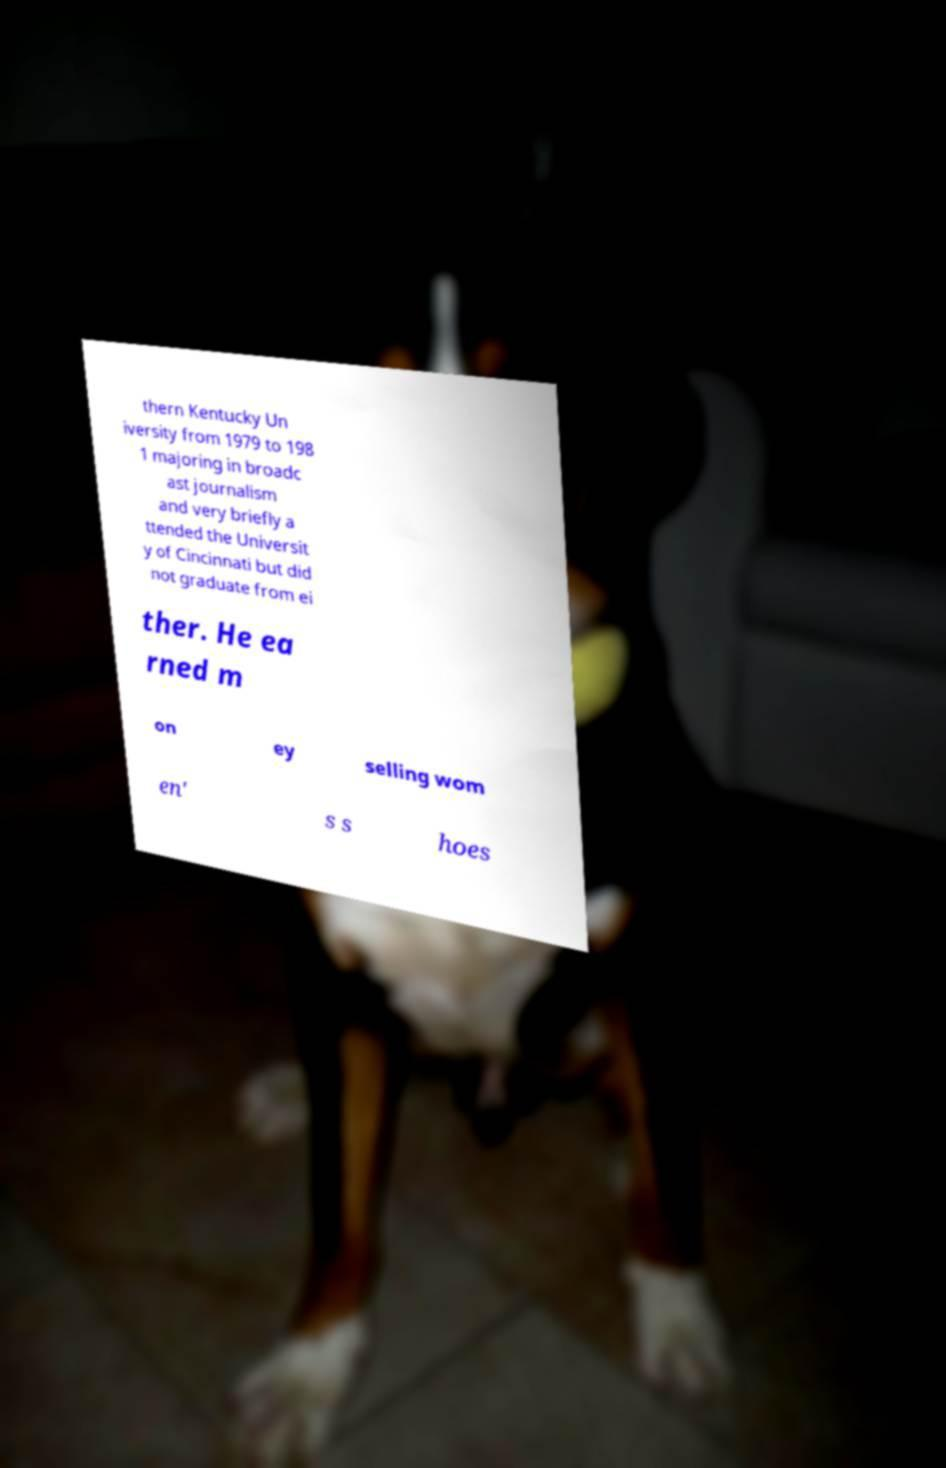Please read and relay the text visible in this image. What does it say? thern Kentucky Un iversity from 1979 to 198 1 majoring in broadc ast journalism and very briefly a ttended the Universit y of Cincinnati but did not graduate from ei ther. He ea rned m on ey selling wom en' s s hoes 